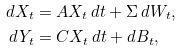Convert formula to latex. <formula><loc_0><loc_0><loc_500><loc_500>d X _ { t } & = A X _ { t } \, d t + \Sigma \, d W _ { t } , \\ d Y _ { t } & = C X _ { t } \, d t + d B _ { t } ,</formula> 